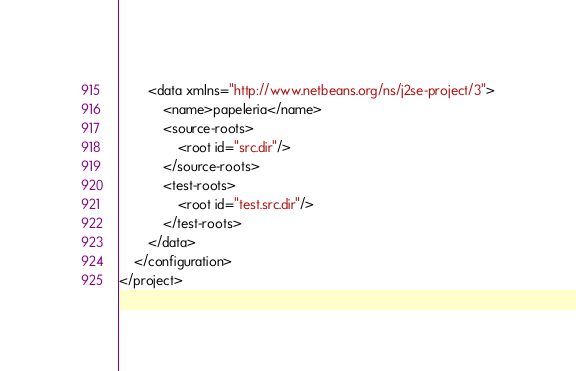<code> <loc_0><loc_0><loc_500><loc_500><_XML_>        <data xmlns="http://www.netbeans.org/ns/j2se-project/3">
            <name>papeleria</name>
            <source-roots>
                <root id="src.dir"/>
            </source-roots>
            <test-roots>
                <root id="test.src.dir"/>
            </test-roots>
        </data>
    </configuration>
</project>
</code> 